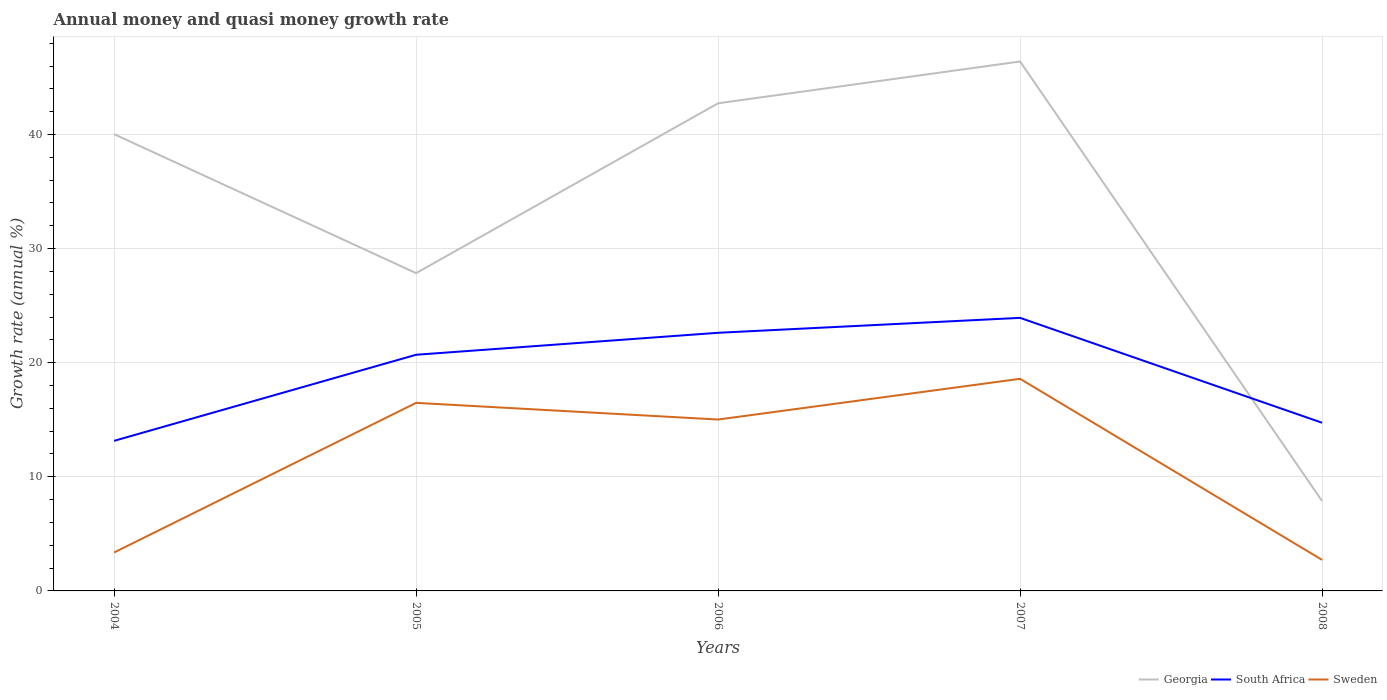Does the line corresponding to South Africa intersect with the line corresponding to Sweden?
Your answer should be compact. No. Across all years, what is the maximum growth rate in Sweden?
Your answer should be compact. 2.72. In which year was the growth rate in South Africa maximum?
Offer a terse response. 2004. What is the total growth rate in South Africa in the graph?
Make the answer very short. -10.78. What is the difference between the highest and the second highest growth rate in Georgia?
Offer a terse response. 38.52. What is the difference between the highest and the lowest growth rate in Sweden?
Make the answer very short. 3. Is the growth rate in South Africa strictly greater than the growth rate in Georgia over the years?
Offer a very short reply. No. How many years are there in the graph?
Your response must be concise. 5. Are the values on the major ticks of Y-axis written in scientific E-notation?
Offer a very short reply. No. Where does the legend appear in the graph?
Make the answer very short. Bottom right. How many legend labels are there?
Ensure brevity in your answer.  3. What is the title of the graph?
Provide a succinct answer. Annual money and quasi money growth rate. Does "St. Kitts and Nevis" appear as one of the legend labels in the graph?
Ensure brevity in your answer.  No. What is the label or title of the Y-axis?
Keep it short and to the point. Growth rate (annual %). What is the Growth rate (annual %) in Georgia in 2004?
Offer a very short reply. 40.03. What is the Growth rate (annual %) in South Africa in 2004?
Keep it short and to the point. 13.15. What is the Growth rate (annual %) in Sweden in 2004?
Your answer should be compact. 3.37. What is the Growth rate (annual %) of Georgia in 2005?
Provide a short and direct response. 27.85. What is the Growth rate (annual %) of South Africa in 2005?
Provide a short and direct response. 20.7. What is the Growth rate (annual %) in Sweden in 2005?
Provide a succinct answer. 16.48. What is the Growth rate (annual %) of Georgia in 2006?
Give a very brief answer. 42.74. What is the Growth rate (annual %) of South Africa in 2006?
Give a very brief answer. 22.62. What is the Growth rate (annual %) in Sweden in 2006?
Provide a short and direct response. 15.02. What is the Growth rate (annual %) of Georgia in 2007?
Offer a terse response. 46.4. What is the Growth rate (annual %) in South Africa in 2007?
Your answer should be very brief. 23.93. What is the Growth rate (annual %) in Sweden in 2007?
Provide a short and direct response. 18.59. What is the Growth rate (annual %) in Georgia in 2008?
Provide a short and direct response. 7.88. What is the Growth rate (annual %) in South Africa in 2008?
Your answer should be compact. 14.74. What is the Growth rate (annual %) in Sweden in 2008?
Provide a short and direct response. 2.72. Across all years, what is the maximum Growth rate (annual %) of Georgia?
Your answer should be very brief. 46.4. Across all years, what is the maximum Growth rate (annual %) in South Africa?
Your answer should be compact. 23.93. Across all years, what is the maximum Growth rate (annual %) of Sweden?
Make the answer very short. 18.59. Across all years, what is the minimum Growth rate (annual %) in Georgia?
Keep it short and to the point. 7.88. Across all years, what is the minimum Growth rate (annual %) in South Africa?
Provide a succinct answer. 13.15. Across all years, what is the minimum Growth rate (annual %) of Sweden?
Your answer should be compact. 2.72. What is the total Growth rate (annual %) of Georgia in the graph?
Ensure brevity in your answer.  164.89. What is the total Growth rate (annual %) of South Africa in the graph?
Your response must be concise. 95.14. What is the total Growth rate (annual %) of Sweden in the graph?
Ensure brevity in your answer.  56.18. What is the difference between the Growth rate (annual %) of Georgia in 2004 and that in 2005?
Ensure brevity in your answer.  12.18. What is the difference between the Growth rate (annual %) in South Africa in 2004 and that in 2005?
Your answer should be compact. -7.54. What is the difference between the Growth rate (annual %) in Sweden in 2004 and that in 2005?
Give a very brief answer. -13.11. What is the difference between the Growth rate (annual %) in Georgia in 2004 and that in 2006?
Make the answer very short. -2.71. What is the difference between the Growth rate (annual %) in South Africa in 2004 and that in 2006?
Your answer should be very brief. -9.47. What is the difference between the Growth rate (annual %) in Sweden in 2004 and that in 2006?
Your answer should be compact. -11.65. What is the difference between the Growth rate (annual %) of Georgia in 2004 and that in 2007?
Your answer should be very brief. -6.37. What is the difference between the Growth rate (annual %) in South Africa in 2004 and that in 2007?
Your response must be concise. -10.78. What is the difference between the Growth rate (annual %) of Sweden in 2004 and that in 2007?
Your answer should be very brief. -15.22. What is the difference between the Growth rate (annual %) of Georgia in 2004 and that in 2008?
Keep it short and to the point. 32.15. What is the difference between the Growth rate (annual %) of South Africa in 2004 and that in 2008?
Provide a short and direct response. -1.59. What is the difference between the Growth rate (annual %) of Sweden in 2004 and that in 2008?
Offer a terse response. 0.65. What is the difference between the Growth rate (annual %) in Georgia in 2005 and that in 2006?
Give a very brief answer. -14.88. What is the difference between the Growth rate (annual %) in South Africa in 2005 and that in 2006?
Your response must be concise. -1.93. What is the difference between the Growth rate (annual %) of Sweden in 2005 and that in 2006?
Make the answer very short. 1.46. What is the difference between the Growth rate (annual %) in Georgia in 2005 and that in 2007?
Ensure brevity in your answer.  -18.55. What is the difference between the Growth rate (annual %) in South Africa in 2005 and that in 2007?
Offer a very short reply. -3.23. What is the difference between the Growth rate (annual %) of Sweden in 2005 and that in 2007?
Keep it short and to the point. -2.11. What is the difference between the Growth rate (annual %) in Georgia in 2005 and that in 2008?
Your response must be concise. 19.97. What is the difference between the Growth rate (annual %) in South Africa in 2005 and that in 2008?
Make the answer very short. 5.96. What is the difference between the Growth rate (annual %) in Sweden in 2005 and that in 2008?
Your answer should be compact. 13.76. What is the difference between the Growth rate (annual %) in Georgia in 2006 and that in 2007?
Your answer should be very brief. -3.66. What is the difference between the Growth rate (annual %) of South Africa in 2006 and that in 2007?
Your answer should be very brief. -1.31. What is the difference between the Growth rate (annual %) in Sweden in 2006 and that in 2007?
Provide a succinct answer. -3.57. What is the difference between the Growth rate (annual %) of Georgia in 2006 and that in 2008?
Give a very brief answer. 34.86. What is the difference between the Growth rate (annual %) of South Africa in 2006 and that in 2008?
Keep it short and to the point. 7.88. What is the difference between the Growth rate (annual %) in Sweden in 2006 and that in 2008?
Provide a short and direct response. 12.3. What is the difference between the Growth rate (annual %) of Georgia in 2007 and that in 2008?
Provide a short and direct response. 38.52. What is the difference between the Growth rate (annual %) of South Africa in 2007 and that in 2008?
Ensure brevity in your answer.  9.19. What is the difference between the Growth rate (annual %) of Sweden in 2007 and that in 2008?
Your answer should be very brief. 15.87. What is the difference between the Growth rate (annual %) of Georgia in 2004 and the Growth rate (annual %) of South Africa in 2005?
Provide a succinct answer. 19.33. What is the difference between the Growth rate (annual %) in Georgia in 2004 and the Growth rate (annual %) in Sweden in 2005?
Keep it short and to the point. 23.55. What is the difference between the Growth rate (annual %) of South Africa in 2004 and the Growth rate (annual %) of Sweden in 2005?
Keep it short and to the point. -3.33. What is the difference between the Growth rate (annual %) in Georgia in 2004 and the Growth rate (annual %) in South Africa in 2006?
Your response must be concise. 17.41. What is the difference between the Growth rate (annual %) of Georgia in 2004 and the Growth rate (annual %) of Sweden in 2006?
Your answer should be compact. 25.01. What is the difference between the Growth rate (annual %) of South Africa in 2004 and the Growth rate (annual %) of Sweden in 2006?
Give a very brief answer. -1.87. What is the difference between the Growth rate (annual %) of Georgia in 2004 and the Growth rate (annual %) of South Africa in 2007?
Ensure brevity in your answer.  16.1. What is the difference between the Growth rate (annual %) in Georgia in 2004 and the Growth rate (annual %) in Sweden in 2007?
Your answer should be compact. 21.44. What is the difference between the Growth rate (annual %) of South Africa in 2004 and the Growth rate (annual %) of Sweden in 2007?
Make the answer very short. -5.44. What is the difference between the Growth rate (annual %) of Georgia in 2004 and the Growth rate (annual %) of South Africa in 2008?
Your response must be concise. 25.29. What is the difference between the Growth rate (annual %) of Georgia in 2004 and the Growth rate (annual %) of Sweden in 2008?
Provide a short and direct response. 37.31. What is the difference between the Growth rate (annual %) of South Africa in 2004 and the Growth rate (annual %) of Sweden in 2008?
Your response must be concise. 10.43. What is the difference between the Growth rate (annual %) of Georgia in 2005 and the Growth rate (annual %) of South Africa in 2006?
Your answer should be very brief. 5.23. What is the difference between the Growth rate (annual %) in Georgia in 2005 and the Growth rate (annual %) in Sweden in 2006?
Your response must be concise. 12.83. What is the difference between the Growth rate (annual %) of South Africa in 2005 and the Growth rate (annual %) of Sweden in 2006?
Offer a terse response. 5.68. What is the difference between the Growth rate (annual %) of Georgia in 2005 and the Growth rate (annual %) of South Africa in 2007?
Your response must be concise. 3.92. What is the difference between the Growth rate (annual %) in Georgia in 2005 and the Growth rate (annual %) in Sweden in 2007?
Give a very brief answer. 9.26. What is the difference between the Growth rate (annual %) of South Africa in 2005 and the Growth rate (annual %) of Sweden in 2007?
Make the answer very short. 2.11. What is the difference between the Growth rate (annual %) in Georgia in 2005 and the Growth rate (annual %) in South Africa in 2008?
Ensure brevity in your answer.  13.11. What is the difference between the Growth rate (annual %) of Georgia in 2005 and the Growth rate (annual %) of Sweden in 2008?
Your answer should be very brief. 25.13. What is the difference between the Growth rate (annual %) in South Africa in 2005 and the Growth rate (annual %) in Sweden in 2008?
Keep it short and to the point. 17.98. What is the difference between the Growth rate (annual %) of Georgia in 2006 and the Growth rate (annual %) of South Africa in 2007?
Offer a terse response. 18.81. What is the difference between the Growth rate (annual %) in Georgia in 2006 and the Growth rate (annual %) in Sweden in 2007?
Keep it short and to the point. 24.15. What is the difference between the Growth rate (annual %) of South Africa in 2006 and the Growth rate (annual %) of Sweden in 2007?
Provide a succinct answer. 4.03. What is the difference between the Growth rate (annual %) in Georgia in 2006 and the Growth rate (annual %) in South Africa in 2008?
Your answer should be very brief. 28. What is the difference between the Growth rate (annual %) in Georgia in 2006 and the Growth rate (annual %) in Sweden in 2008?
Offer a very short reply. 40.02. What is the difference between the Growth rate (annual %) in South Africa in 2006 and the Growth rate (annual %) in Sweden in 2008?
Your answer should be very brief. 19.9. What is the difference between the Growth rate (annual %) of Georgia in 2007 and the Growth rate (annual %) of South Africa in 2008?
Give a very brief answer. 31.66. What is the difference between the Growth rate (annual %) in Georgia in 2007 and the Growth rate (annual %) in Sweden in 2008?
Ensure brevity in your answer.  43.68. What is the difference between the Growth rate (annual %) of South Africa in 2007 and the Growth rate (annual %) of Sweden in 2008?
Give a very brief answer. 21.21. What is the average Growth rate (annual %) of Georgia per year?
Your answer should be very brief. 32.98. What is the average Growth rate (annual %) in South Africa per year?
Your answer should be compact. 19.03. What is the average Growth rate (annual %) in Sweden per year?
Offer a very short reply. 11.24. In the year 2004, what is the difference between the Growth rate (annual %) of Georgia and Growth rate (annual %) of South Africa?
Your answer should be compact. 26.88. In the year 2004, what is the difference between the Growth rate (annual %) in Georgia and Growth rate (annual %) in Sweden?
Keep it short and to the point. 36.66. In the year 2004, what is the difference between the Growth rate (annual %) of South Africa and Growth rate (annual %) of Sweden?
Make the answer very short. 9.78. In the year 2005, what is the difference between the Growth rate (annual %) in Georgia and Growth rate (annual %) in South Africa?
Your answer should be very brief. 7.15. In the year 2005, what is the difference between the Growth rate (annual %) in Georgia and Growth rate (annual %) in Sweden?
Your answer should be very brief. 11.37. In the year 2005, what is the difference between the Growth rate (annual %) in South Africa and Growth rate (annual %) in Sweden?
Give a very brief answer. 4.22. In the year 2006, what is the difference between the Growth rate (annual %) of Georgia and Growth rate (annual %) of South Africa?
Offer a very short reply. 20.11. In the year 2006, what is the difference between the Growth rate (annual %) of Georgia and Growth rate (annual %) of Sweden?
Your answer should be very brief. 27.71. In the year 2006, what is the difference between the Growth rate (annual %) in South Africa and Growth rate (annual %) in Sweden?
Offer a very short reply. 7.6. In the year 2007, what is the difference between the Growth rate (annual %) of Georgia and Growth rate (annual %) of South Africa?
Provide a short and direct response. 22.47. In the year 2007, what is the difference between the Growth rate (annual %) of Georgia and Growth rate (annual %) of Sweden?
Your answer should be very brief. 27.81. In the year 2007, what is the difference between the Growth rate (annual %) of South Africa and Growth rate (annual %) of Sweden?
Make the answer very short. 5.34. In the year 2008, what is the difference between the Growth rate (annual %) of Georgia and Growth rate (annual %) of South Africa?
Provide a short and direct response. -6.86. In the year 2008, what is the difference between the Growth rate (annual %) in Georgia and Growth rate (annual %) in Sweden?
Offer a very short reply. 5.16. In the year 2008, what is the difference between the Growth rate (annual %) of South Africa and Growth rate (annual %) of Sweden?
Provide a short and direct response. 12.02. What is the ratio of the Growth rate (annual %) in Georgia in 2004 to that in 2005?
Offer a very short reply. 1.44. What is the ratio of the Growth rate (annual %) in South Africa in 2004 to that in 2005?
Make the answer very short. 0.64. What is the ratio of the Growth rate (annual %) of Sweden in 2004 to that in 2005?
Ensure brevity in your answer.  0.2. What is the ratio of the Growth rate (annual %) of Georgia in 2004 to that in 2006?
Give a very brief answer. 0.94. What is the ratio of the Growth rate (annual %) of South Africa in 2004 to that in 2006?
Give a very brief answer. 0.58. What is the ratio of the Growth rate (annual %) of Sweden in 2004 to that in 2006?
Offer a very short reply. 0.22. What is the ratio of the Growth rate (annual %) of Georgia in 2004 to that in 2007?
Ensure brevity in your answer.  0.86. What is the ratio of the Growth rate (annual %) of South Africa in 2004 to that in 2007?
Your answer should be compact. 0.55. What is the ratio of the Growth rate (annual %) of Sweden in 2004 to that in 2007?
Your response must be concise. 0.18. What is the ratio of the Growth rate (annual %) in Georgia in 2004 to that in 2008?
Keep it short and to the point. 5.08. What is the ratio of the Growth rate (annual %) in South Africa in 2004 to that in 2008?
Offer a very short reply. 0.89. What is the ratio of the Growth rate (annual %) in Sweden in 2004 to that in 2008?
Keep it short and to the point. 1.24. What is the ratio of the Growth rate (annual %) of Georgia in 2005 to that in 2006?
Offer a terse response. 0.65. What is the ratio of the Growth rate (annual %) in South Africa in 2005 to that in 2006?
Your answer should be compact. 0.91. What is the ratio of the Growth rate (annual %) of Sweden in 2005 to that in 2006?
Make the answer very short. 1.1. What is the ratio of the Growth rate (annual %) of Georgia in 2005 to that in 2007?
Give a very brief answer. 0.6. What is the ratio of the Growth rate (annual %) in South Africa in 2005 to that in 2007?
Provide a succinct answer. 0.86. What is the ratio of the Growth rate (annual %) of Sweden in 2005 to that in 2007?
Your response must be concise. 0.89. What is the ratio of the Growth rate (annual %) in Georgia in 2005 to that in 2008?
Your response must be concise. 3.54. What is the ratio of the Growth rate (annual %) in South Africa in 2005 to that in 2008?
Ensure brevity in your answer.  1.4. What is the ratio of the Growth rate (annual %) in Sweden in 2005 to that in 2008?
Provide a short and direct response. 6.06. What is the ratio of the Growth rate (annual %) of Georgia in 2006 to that in 2007?
Ensure brevity in your answer.  0.92. What is the ratio of the Growth rate (annual %) in South Africa in 2006 to that in 2007?
Your answer should be very brief. 0.95. What is the ratio of the Growth rate (annual %) in Sweden in 2006 to that in 2007?
Ensure brevity in your answer.  0.81. What is the ratio of the Growth rate (annual %) of Georgia in 2006 to that in 2008?
Keep it short and to the point. 5.43. What is the ratio of the Growth rate (annual %) in South Africa in 2006 to that in 2008?
Provide a short and direct response. 1.53. What is the ratio of the Growth rate (annual %) of Sweden in 2006 to that in 2008?
Your answer should be very brief. 5.52. What is the ratio of the Growth rate (annual %) of Georgia in 2007 to that in 2008?
Offer a very short reply. 5.89. What is the ratio of the Growth rate (annual %) in South Africa in 2007 to that in 2008?
Give a very brief answer. 1.62. What is the ratio of the Growth rate (annual %) in Sweden in 2007 to that in 2008?
Keep it short and to the point. 6.84. What is the difference between the highest and the second highest Growth rate (annual %) of Georgia?
Your answer should be very brief. 3.66. What is the difference between the highest and the second highest Growth rate (annual %) of South Africa?
Ensure brevity in your answer.  1.31. What is the difference between the highest and the second highest Growth rate (annual %) in Sweden?
Provide a short and direct response. 2.11. What is the difference between the highest and the lowest Growth rate (annual %) of Georgia?
Provide a succinct answer. 38.52. What is the difference between the highest and the lowest Growth rate (annual %) of South Africa?
Make the answer very short. 10.78. What is the difference between the highest and the lowest Growth rate (annual %) of Sweden?
Keep it short and to the point. 15.87. 